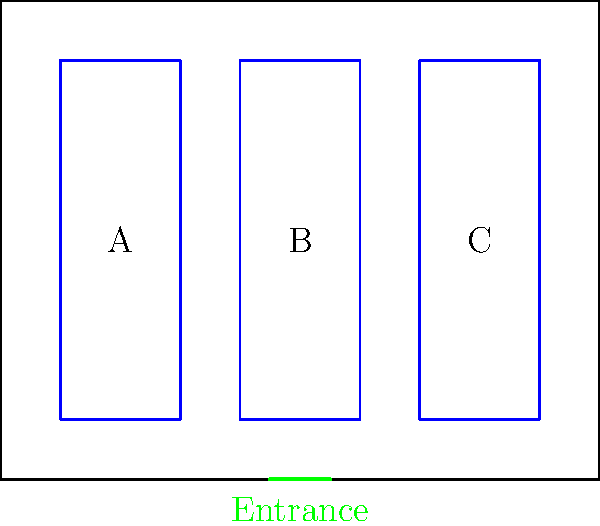In the diagram above, three shelving units (A, B, and C) are arranged in a general store. The store owner wants to maximize space efficiency while ensuring easy customer flow. Which arrangement of the shelving units would be most effective, considering historical retail practices and modern space utilization techniques? To determine the most effective arrangement of shelving units, we need to consider several factors based on historical retail practices and modern space utilization techniques:

1. Customer Flow: Historically, stores aimed to guide customers through the entire space to maximize exposure to products. The current layout achieves this by creating two aisles.

2. Visibility: All shelves should be visible from the entrance to attract customers. The current arrangement allows this.

3. Traffic Distribution: Spreading out popular items helps distribute foot traffic. The three separate units allow for this strategy.

4. Flexibility: Multiple smaller units offer more flexibility for rearrangement than fewer larger units.

5. Aisle Width: The space between shelves should be wide enough for comfortable browsing. The current layout provides sufficient aisle width.

6. Entrance Proximity: Placing high-turnover items near the entrance encourages quick sales. Unit B is ideally positioned for this purpose.

7. Wall Utilization: Historically, stores often used walls for shelving to maximize floor space. The current layout leaves wall space available.

Given these considerations, the current arrangement (A-B-C from left to right) is highly effective. It creates a logical flow, utilizes space efficiently, and aligns with both historical and modern retail practices.

However, a slight improvement could be made by swapping units A and C. This would place the larger unit (C) closer to the entrance, potentially showcasing more products immediately to entering customers while maintaining the overall efficient layout.
Answer: C-B-A (from left to right) 